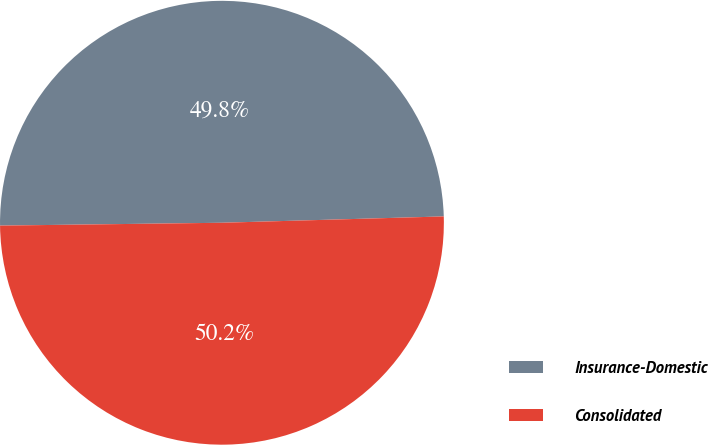Convert chart to OTSL. <chart><loc_0><loc_0><loc_500><loc_500><pie_chart><fcel>Insurance-Domestic<fcel>Consolidated<nl><fcel>49.75%<fcel>50.25%<nl></chart> 